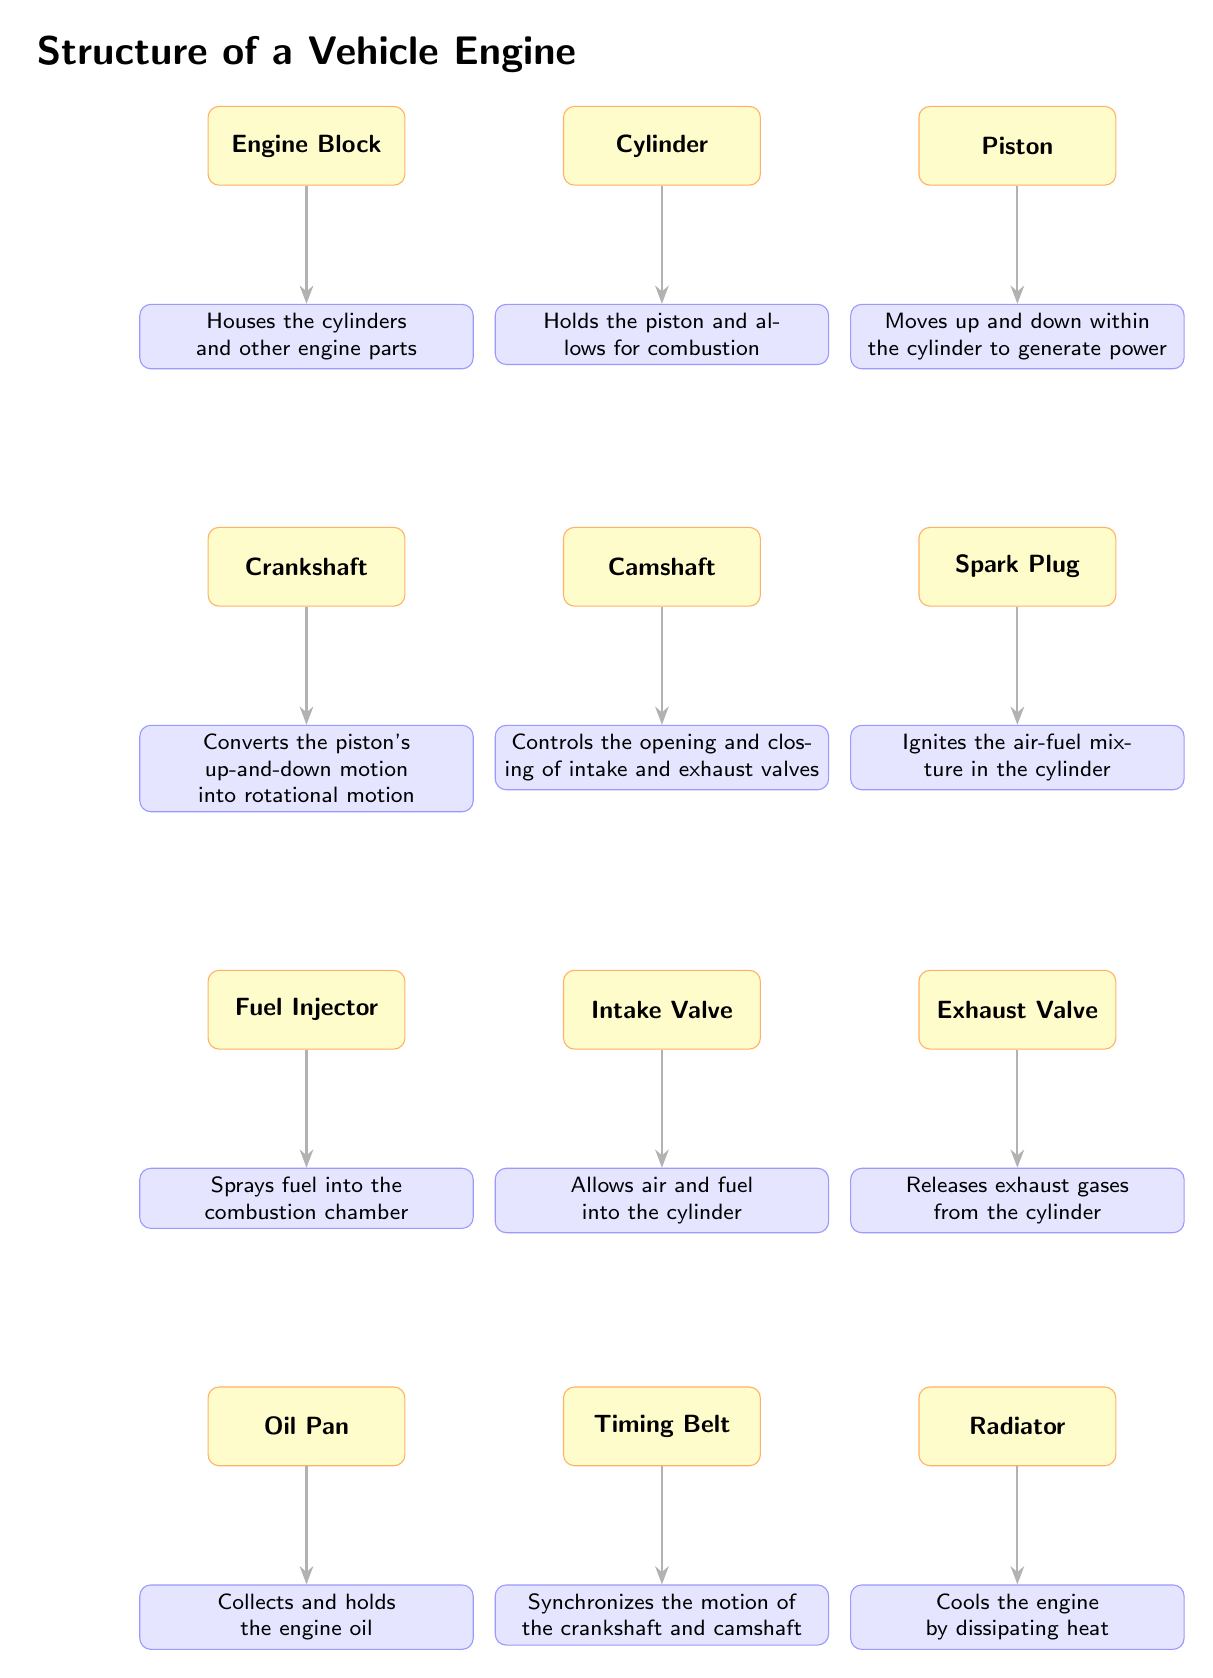What component houses the cylinders? The diagram indicates that the Engine Block is the component that houses the cylinders and other engine parts, as described in the function associated with it.
Answer: Engine Block What does the piston do? According to the diagram, the function of the piston is to move up and down within the cylinder to generate power, which is explicitly stated below the piston component.
Answer: Moves up and down within the cylinder to generate power How many components are labeled in the diagram? By counting each component listed in the diagram, we find there are a total of 10 distinct components labeled.
Answer: 10 Which component controls the opening and closing of intake and exhaust valves? The diagram shows that the Camshaft is responsible for controlling the opening and closing of intake and exhaust valves, as detailed in its function.
Answer: Camshaft What is the role of the Timing Belt? The Timing Belt is specified in the diagram to synchronize the motion of the crankshaft and camshaft, based on the description provided under its component.
Answer: Synchronizes the motion of the crankshaft and camshaft What component releases exhaust gases from the cylinder? The diagram indicates that the Exhaust Valve is the component that releases exhaust gases from the cylinder, which is described under its function.
Answer: Exhaust Valve What connects the Engine Block to the Pistons? The relationship in the diagram suggests that the Cylinders connect the Engine Block to the Pistons, as the pistons reside within the cylinders that are housed in the engine block.
Answer: Cylinders What does the Fuel Injector do? The diagram states that the Fuel Injector sprays fuel into the combustion chamber, which is its designated function shown visually.
Answer: Sprays fuel into the combustion chamber Which component ignites the air-fuel mixture? According to the diagram, the Spark Plug is responsible for igniting the air-fuel mixture in the cylinder, as described directly below it.
Answer: Spark Plug What is the purpose of the Radiator? The diagram explains that the Radiator cools the engine by dissipating heat, providing clarity on its function.
Answer: Cools the engine by dissipating heat 